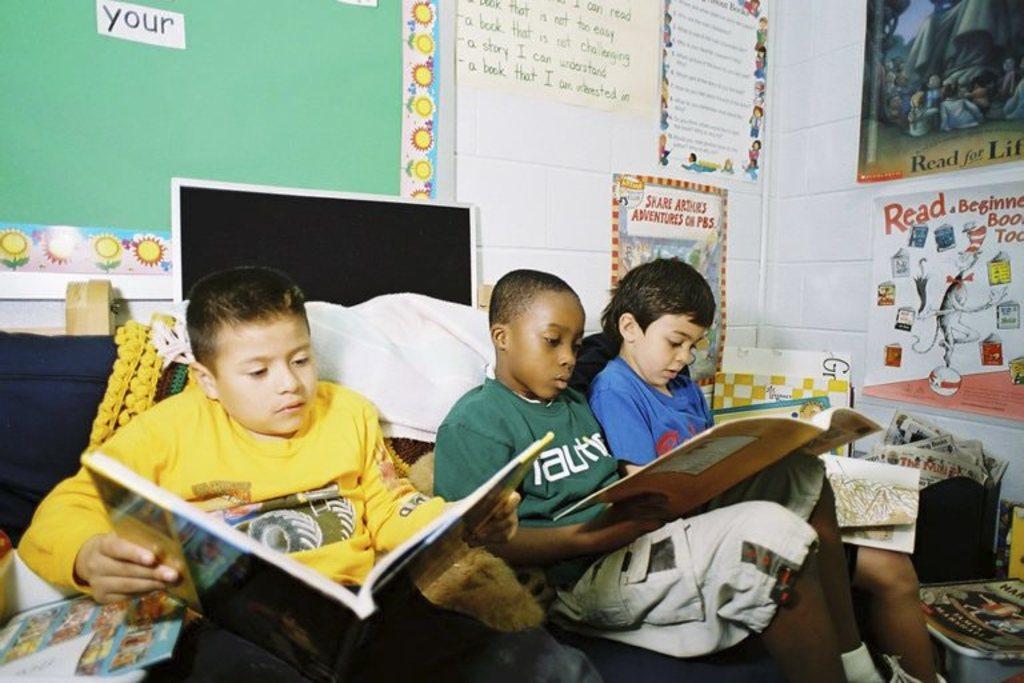What brand is the green shirt?
Your answer should be very brief. Nautica. 